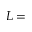Convert formula to latex. <formula><loc_0><loc_0><loc_500><loc_500>L =</formula> 